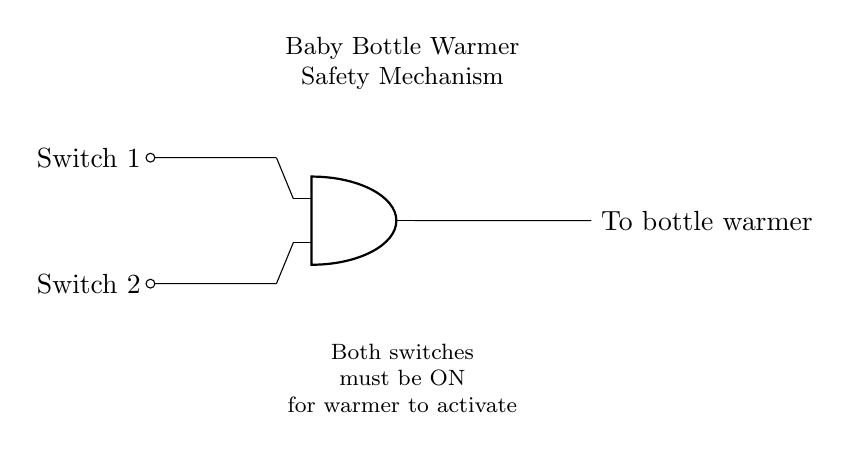What are the input components in the circuit? The input components are Switch 1 and Switch 2, which are positioned at the left side of the diagram and are connected directly to the AND gate.
Answer: Switch 1 and Switch 2 How many input switches are required for the AND gate to function? The AND gate requires two inputs, as indicated by the two connections leading from Switch 1 and Switch 2 to the AND gate.
Answer: Two What happens to the bottle warmer if one switch is turned OFF? The output to the bottle warmer is dependent on both switches being ON; thus, if one is OFF, the warmer will not activate.
Answer: It remains OFF What type of logic gate is used in this circuit? The circuit utilizes an AND gate, as shown by the specific symbol labeled in the diagram and its functionality requiring both inputs to be ON for activation.
Answer: AND gate How is the output of the AND gate connected? The output of the AND gate is connected directly to the bottle warmer, as indicated by the line leading from the AND gate's output to the labeled terminal for the warmer connection.
Answer: To bottle warmer What do both switches create together in this safety mechanism? Both switches work in parallel to serve as a safety mechanism that ensures the baby bottle warmer only activates when both are ON, indicating a safe operating state.
Answer: Safety mechanism Why is it necessary for both switches to be ON for operation? This design minimizes the risk of accidental activation, ensuring that the warmer is only functional when both controls are engaged, enhancing safety for the user.
Answer: For safety 